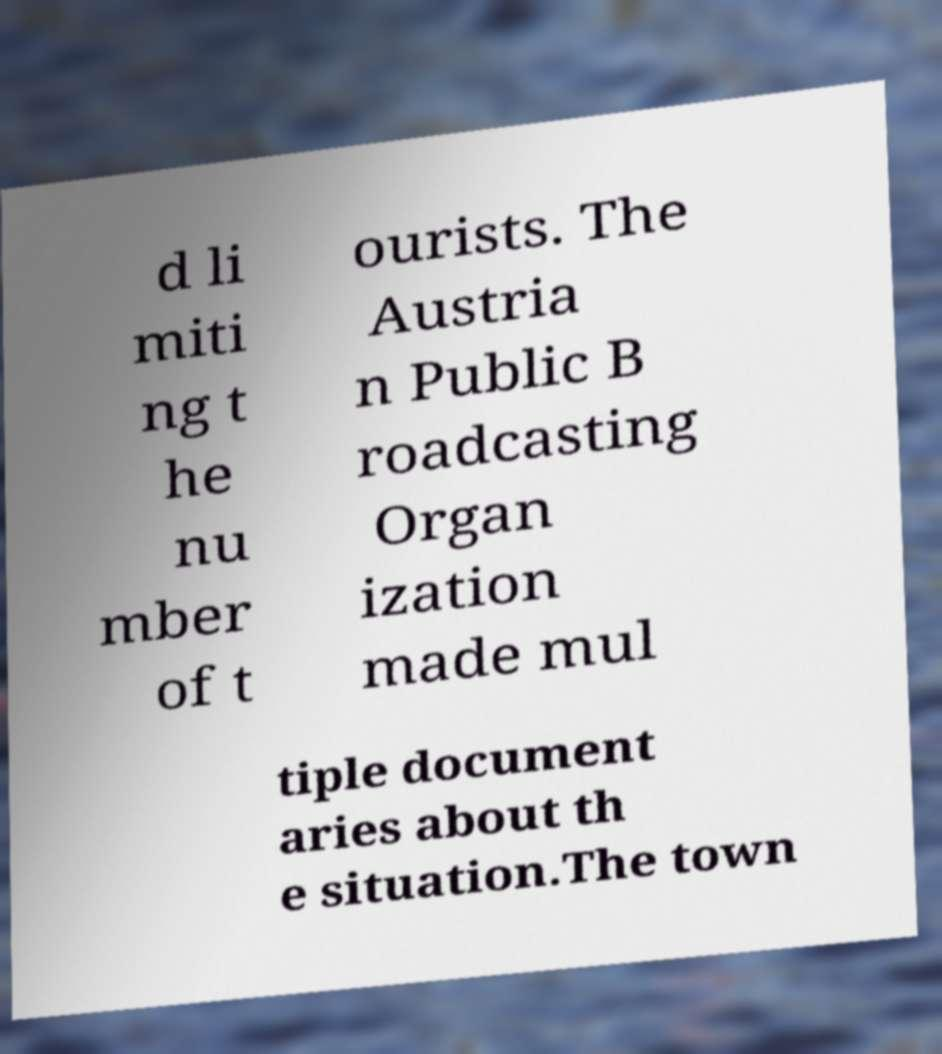For documentation purposes, I need the text within this image transcribed. Could you provide that? d li miti ng t he nu mber of t ourists. The Austria n Public B roadcasting Organ ization made mul tiple document aries about th e situation.The town 